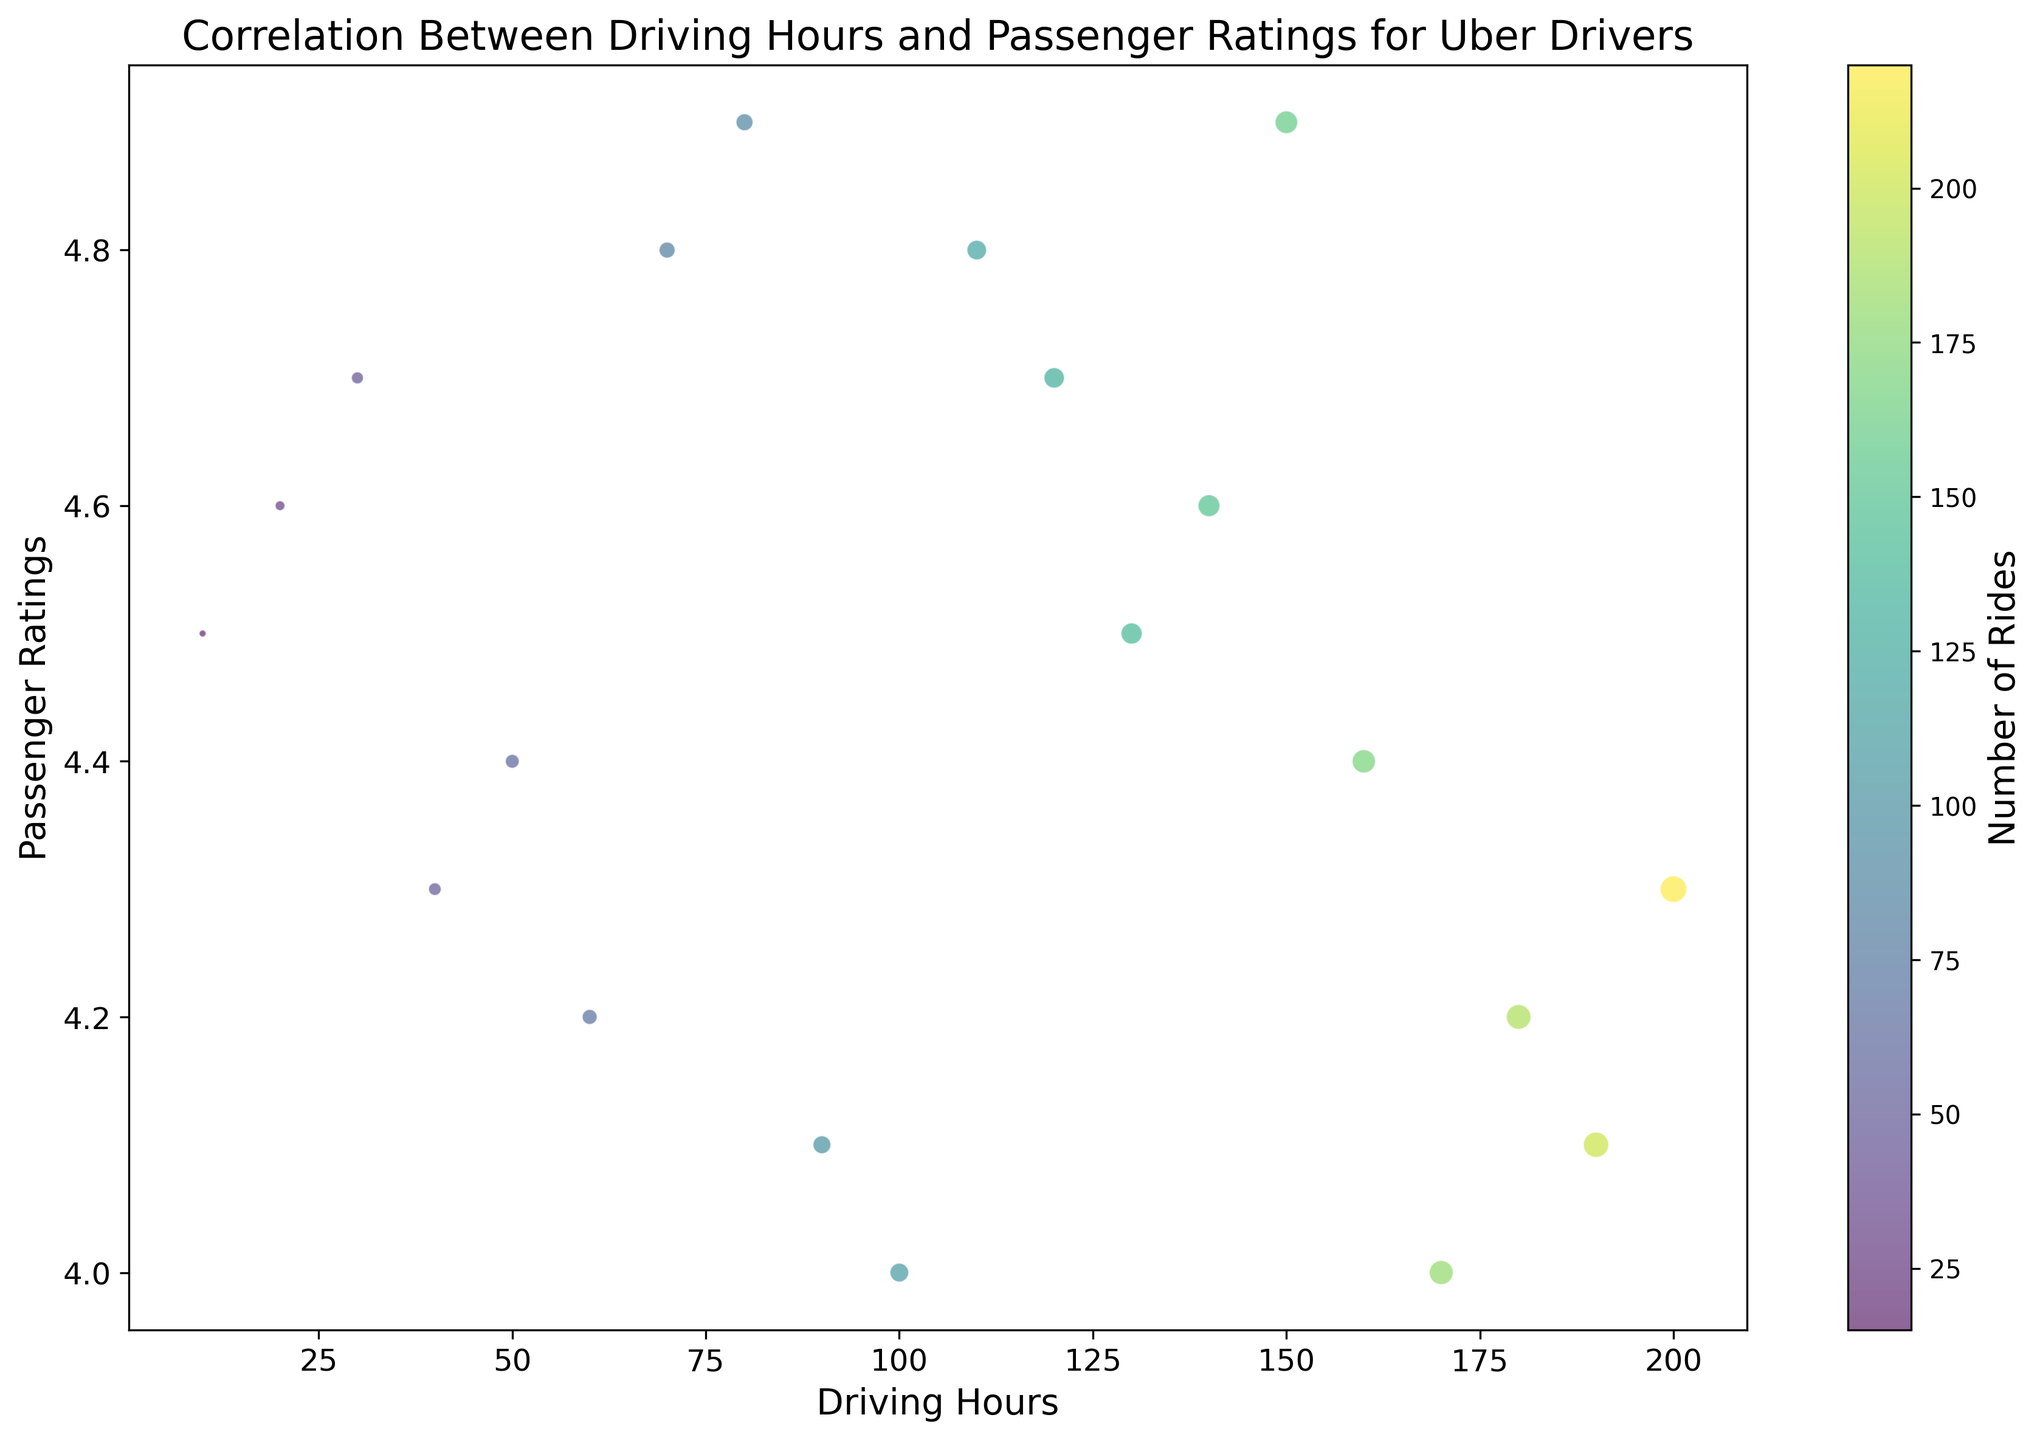How does the number of rides vary with driving hours? Look at the size of the circles, which represent the number of rides for each driving hour category. Larger circles indicate more rides. For example, 200 driving hours have the largest circle, indicating the highest number of rides.
Answer: The number of rides increases with driving hours Which driving hour category has the highest passenger rating? Observe the y-axis for passenger ratings and find the highest value. The category with 80 driving hours shows a rating of 4.9, the highest among all.
Answer: 80 driving hours At what driving hour is the passenger rating the lowest? Look at the y-axis for the lowest passenger rating. 170 and 100 driving hours both have the lowest rating of 4.0.
Answer: 170 and 100 driving hours What can be said about the correlation between driving hours and passenger ratings? Notice the overall trend of the scatter plot. While there are fluctuations, ratings do not consistently increase or decrease with driving hours, showing a weak or no clear correlation.
Answer: No clear correlation Which two driving hour categories have a very similar number of rides but differ significantly in passenger ratings? Compare the sizes and colors of the circles to find similar bubble sizes but different vertical positions. 190 and 200 driving hours have similar bubble sizes (indicating rides) but ratings of 4.1 and 4.3 respectively.
Answer: 190 and 200 driving hours Is there any group where a high number of driving hours corresponds to a high passenger rating? Identify the groups with high values on both the driving hours axis and the passenger rating axis. 150 driving hours, with a passenger rating of 4.9, stands out.
Answer: 150 driving hours Which driving hour category has the smallest number of rides? Look for the smallest bubble. 10 driving hours has the smallest bubble, corresponding to the lowest number of rides.
Answer: 10 driving hours Are there any cases where fewer driving hours correlate with a high passenger rating? Find groups where driving hours are low but the ratings are high on the y-axis. 10 and 20 driving hours have ratings of 4.5 and 4.6 respectively.
Answer: 10 and 20 driving hours What is the range of passenger ratings for drivers who drive more than 100 hours? Observe the span of passenger rating values for driving hours greater than 100. The ratings range from 4.0 to 4.9.
Answer: 4.0 to 4.9 How does the number of rides for drivers who drive 50 hours compare to those who drive 150 hours? Compare the size of the bubbles for 50 and 150 driving hours. The bubble for 150 hours is larger, indicating more rides.
Answer: More for 150 hours 